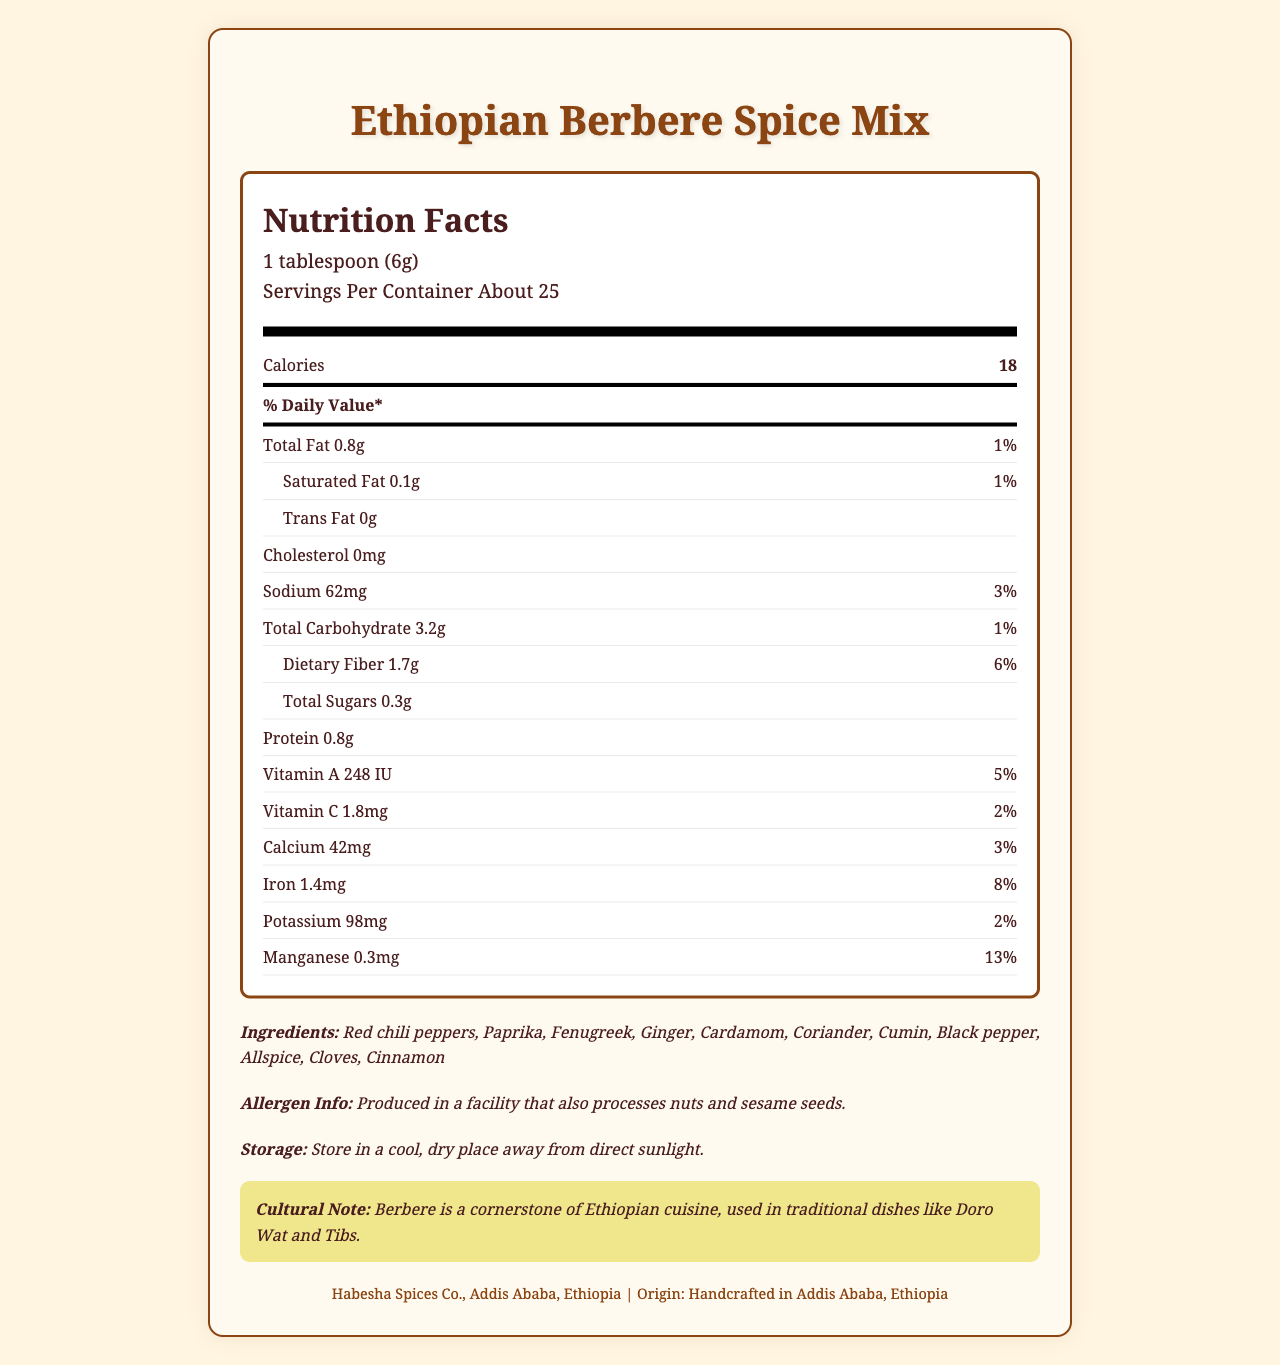what is the amount of dietary fiber per serving? The document states that the amount of dietary fiber per serving is 1.7g.
Answer: 1.7g how much potassium is in one serving of the Berbere spice mix? The nutrition label specifies that one serving of the Berbere spice mix contains 98mg of potassium.
Answer: 98mg what percentage of the daily value of iron does one serving provide? The label shows that one serving of the spice mix provides 8% of the daily iron value.
Answer: 8% what is the origin of the Ethiopian Berbere Spice Mix? According to the document, the spice mix is handcrafted in Addis Ababa, Ethiopia.
Answer: Handcrafted in Addis Ababa, Ethiopia how should the Berbere spice mix be stored? The storage instructions state that the spice should be kept in a cool, dry place away from direct sunlight.
Answer: Store in a cool, dry place away from direct sunlight which nutrient has the highest daily value percentage per serving? A. Calcium B. Manganese C. Vitamin A D. Sodium Manganese has the highest daily value percentage at 13%, compared to Calcium (3%), Vitamin A (5%), and Sodium (3%).
Answer: B. Manganese how many servings per container does the product have? The document lists that there are about 25 servings per container.
Answer: About 25 is there cholesterol in the Berbere spice mix? The label notes that there is 0mg of cholesterol in the spice mix.
Answer: No which ingredient is not listed in the Berbere spice mix? A. Red chili peppers B. Paprika C. Garlic D. Cloves Garlic is not listed among the ingredients, while Red chili peppers, Paprika, and Cloves are listed.
Answer: C. Garlic can someone with a nut allergy safely consume this product? The allergen information indicates that the product is produced in a facility that also processes nuts, so it may not be safe for someone with a nut allergy.
Answer: No summarize the main information provided in this document. This document outlines the nutritional content, ingredient list, and additional details for Ethiopian Berbere Spice Mix. It highlights the serving size, the nutrient amounts per serving, allergen warnings, how to store the product, its cultural importance, and the manufacturer.
Answer: The document provides the nutrition facts for Ethiopian Berbere Spice Mix including serving size, calorie content, and amounts of various nutrients. It lists the ingredients, allergen information, storage instructions, cultural significance, and manufacturer details. how many grams of total fat are in a serving? The nutrition label states that there are 0.8g of total fat per serving.
Answer: 0.8g what is the daily value percentage of vitamin C per serving? The document indicates that the vitamin C daily value per serving is 2%.
Answer: 2% what is the cultural significance of Berbere in Ethiopian cuisine? The cultural note mentions that Berbere is a cornerstone of Ethiopian cuisine and is used in traditional dishes like Doro Wat and Tibs.
Answer: Used in traditional dishes like Doro Wat and Tibs does the product contain added sugars? The document mentions total sugars but does not specify if they are added sugars.
Answer: Not enough information what is the calorie content for two servings? Since one serving contains 18 calories, two servings would contain 36 calories (18 * 2).
Answer: 36 calories 